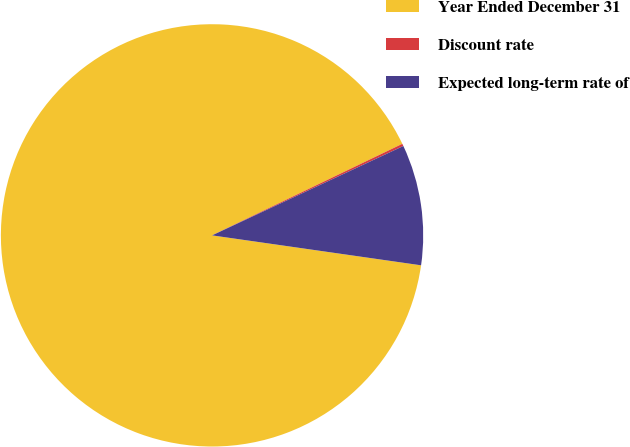Convert chart. <chart><loc_0><loc_0><loc_500><loc_500><pie_chart><fcel>Year Ended December 31<fcel>Discount rate<fcel>Expected long-term rate of<nl><fcel>90.6%<fcel>0.18%<fcel>9.22%<nl></chart> 